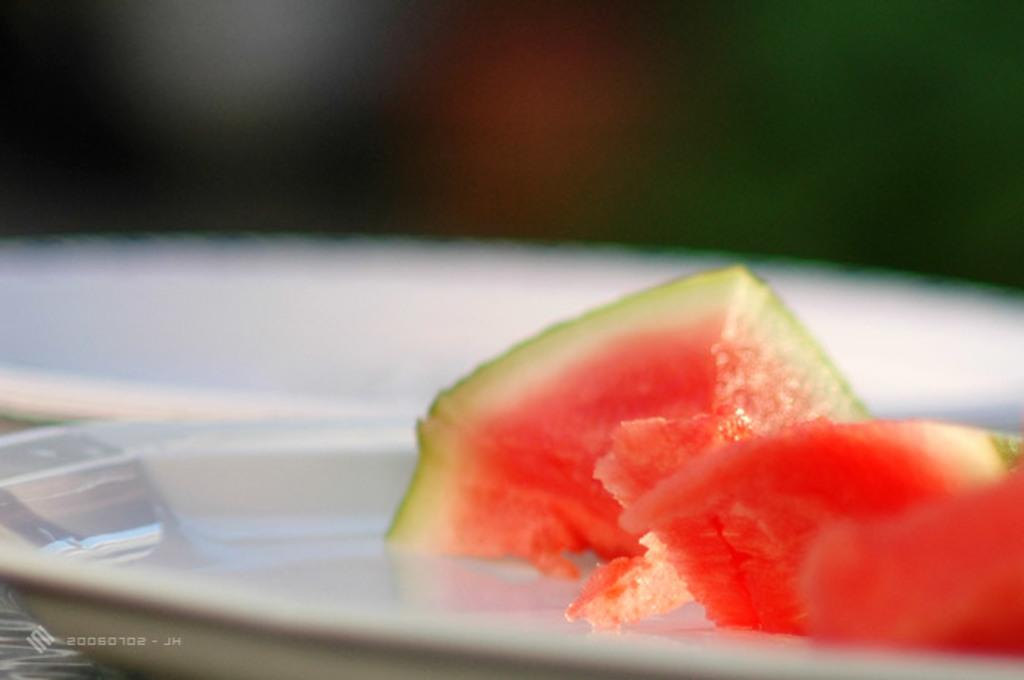What is the main subject of the image? The main subject of the image is food. How is the food presented in the image? The food is on a plate. Can you describe the background of the image? The backdrop of the image is blurred. Is there any text or symbols present in the image? Yes, there is a code printed on the left side bottom of the image. How many maids are visible in the image? There are no maids present in the image. What type of pencil can be seen being used to draw on the plate? There is no pencil visible in the image, and the plate does not have any drawings on it. 